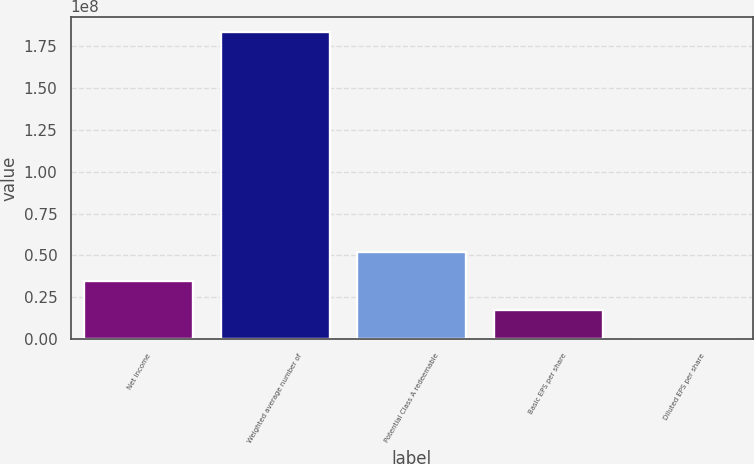Convert chart to OTSL. <chart><loc_0><loc_0><loc_500><loc_500><bar_chart><fcel>Net income<fcel>Weighted average number of<fcel>Potential Class A redeemable<fcel>Basic EPS per share<fcel>Diluted EPS per share<nl><fcel>3.4665e+07<fcel>1.83348e+08<fcel>5.19975e+07<fcel>1.73325e+07<fcel>1.63<nl></chart> 